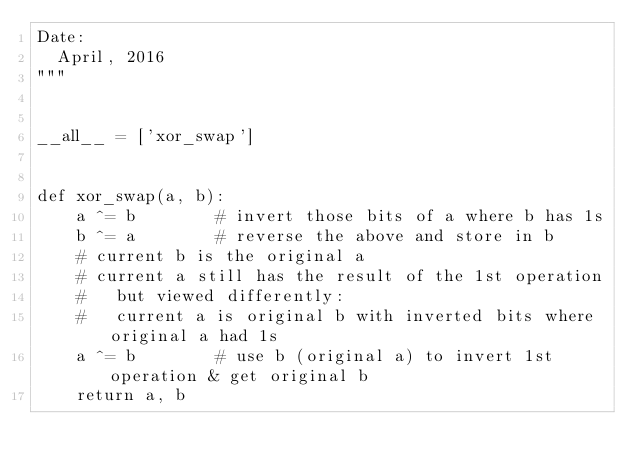<code> <loc_0><loc_0><loc_500><loc_500><_Python_>Date:
  April, 2016
"""


__all__ = ['xor_swap']


def xor_swap(a, b):
    a ^= b        # invert those bits of a where b has 1s
    b ^= a        # reverse the above and store in b
    # current b is the original a
    # current a still has the result of the 1st operation
    #   but viewed differently:
    #   current a is original b with inverted bits where original a had 1s
    a ^= b        # use b (original a) to invert 1st operation & get original b
    return a, b
</code> 